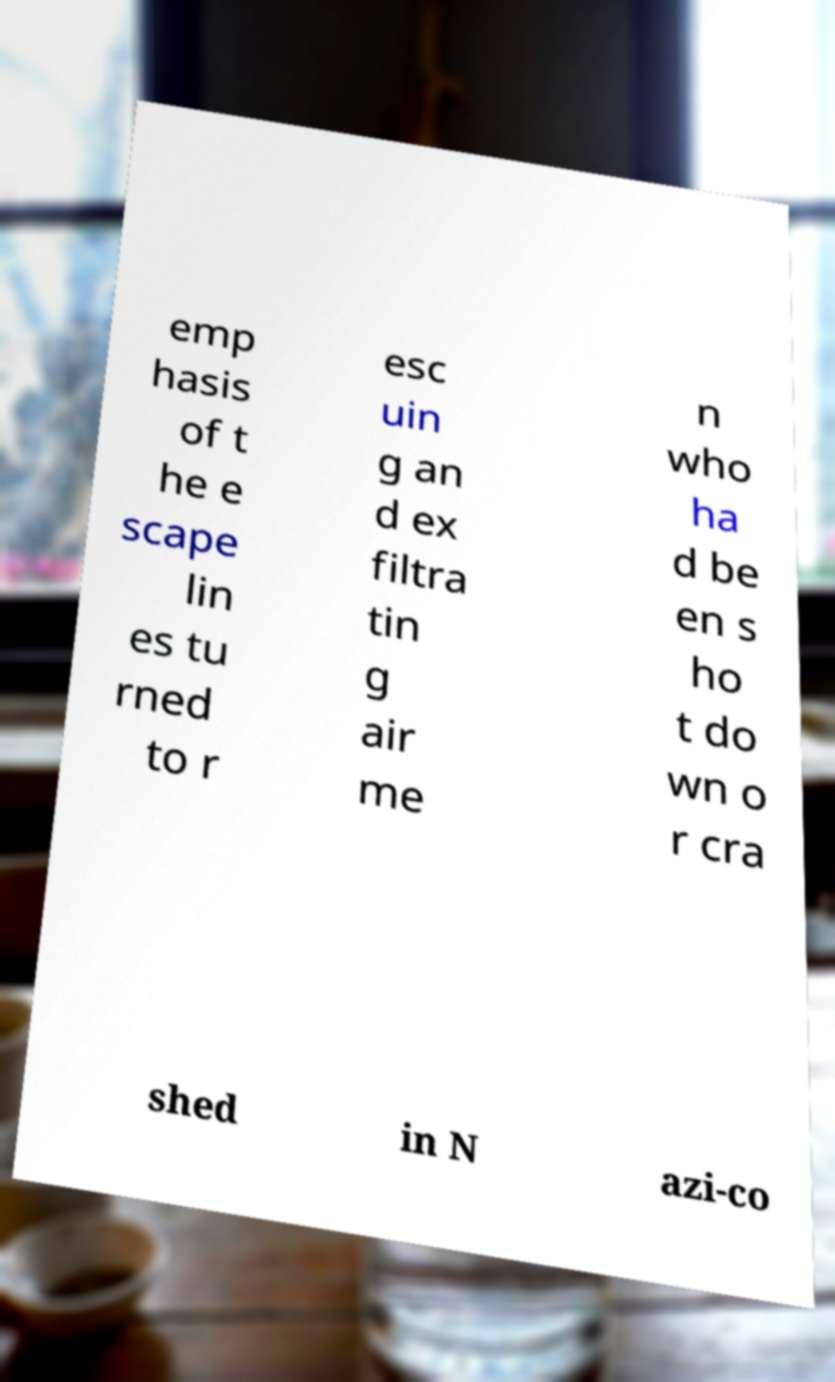What messages or text are displayed in this image? I need them in a readable, typed format. emp hasis of t he e scape lin es tu rned to r esc uin g an d ex filtra tin g air me n who ha d be en s ho t do wn o r cra shed in N azi-co 